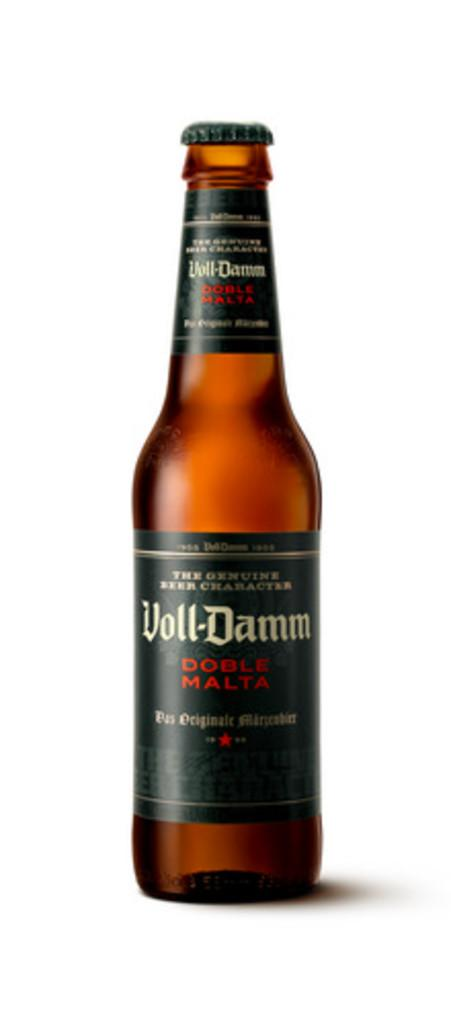<image>
Render a clear and concise summary of the photo. Bottle of Voll-Damm Doble Malta in Red the genuine beer character. 